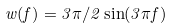<formula> <loc_0><loc_0><loc_500><loc_500>w ( f ) = 3 \pi / 2 \sin ( 3 \pi f )</formula> 